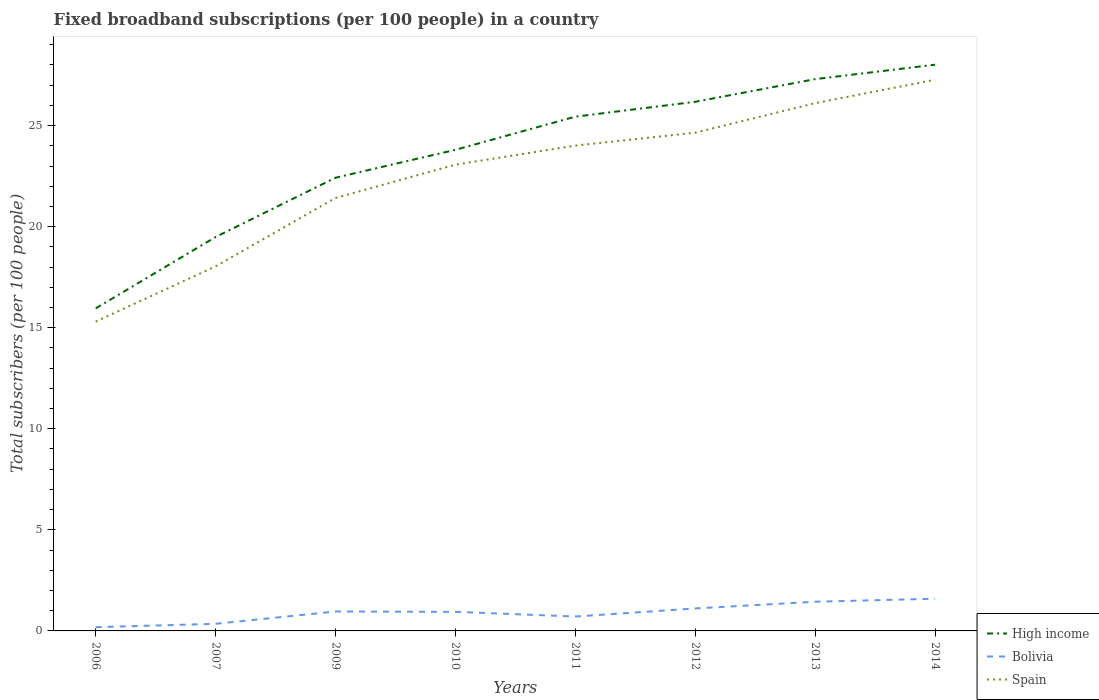Across all years, what is the maximum number of broadband subscriptions in Bolivia?
Provide a short and direct response. 0.18. In which year was the number of broadband subscriptions in Spain maximum?
Give a very brief answer. 2006. What is the total number of broadband subscriptions in Spain in the graph?
Your answer should be very brief. -5.85. What is the difference between the highest and the second highest number of broadband subscriptions in Spain?
Provide a succinct answer. 11.97. Are the values on the major ticks of Y-axis written in scientific E-notation?
Your answer should be compact. No. Does the graph contain any zero values?
Provide a short and direct response. No. Does the graph contain grids?
Keep it short and to the point. No. How many legend labels are there?
Your response must be concise. 3. How are the legend labels stacked?
Give a very brief answer. Vertical. What is the title of the graph?
Offer a terse response. Fixed broadband subscriptions (per 100 people) in a country. What is the label or title of the X-axis?
Provide a short and direct response. Years. What is the label or title of the Y-axis?
Provide a succinct answer. Total subscribers (per 100 people). What is the Total subscribers (per 100 people) in High income in 2006?
Make the answer very short. 15.96. What is the Total subscribers (per 100 people) of Bolivia in 2006?
Offer a terse response. 0.18. What is the Total subscribers (per 100 people) of Spain in 2006?
Provide a short and direct response. 15.3. What is the Total subscribers (per 100 people) in High income in 2007?
Your answer should be very brief. 19.49. What is the Total subscribers (per 100 people) of Bolivia in 2007?
Your response must be concise. 0.35. What is the Total subscribers (per 100 people) of Spain in 2007?
Offer a very short reply. 18.04. What is the Total subscribers (per 100 people) of High income in 2009?
Make the answer very short. 22.42. What is the Total subscribers (per 100 people) in Bolivia in 2009?
Provide a short and direct response. 0.96. What is the Total subscribers (per 100 people) of Spain in 2009?
Give a very brief answer. 21.42. What is the Total subscribers (per 100 people) in High income in 2010?
Ensure brevity in your answer.  23.8. What is the Total subscribers (per 100 people) of Bolivia in 2010?
Keep it short and to the point. 0.94. What is the Total subscribers (per 100 people) in Spain in 2010?
Your answer should be compact. 23.07. What is the Total subscribers (per 100 people) of High income in 2011?
Give a very brief answer. 25.44. What is the Total subscribers (per 100 people) in Bolivia in 2011?
Keep it short and to the point. 0.71. What is the Total subscribers (per 100 people) of Spain in 2011?
Make the answer very short. 24.01. What is the Total subscribers (per 100 people) of High income in 2012?
Ensure brevity in your answer.  26.18. What is the Total subscribers (per 100 people) in Bolivia in 2012?
Ensure brevity in your answer.  1.11. What is the Total subscribers (per 100 people) of Spain in 2012?
Provide a short and direct response. 24.65. What is the Total subscribers (per 100 people) of High income in 2013?
Your response must be concise. 27.3. What is the Total subscribers (per 100 people) in Bolivia in 2013?
Offer a very short reply. 1.44. What is the Total subscribers (per 100 people) in Spain in 2013?
Make the answer very short. 26.11. What is the Total subscribers (per 100 people) of High income in 2014?
Provide a succinct answer. 28.01. What is the Total subscribers (per 100 people) of Bolivia in 2014?
Ensure brevity in your answer.  1.59. What is the Total subscribers (per 100 people) in Spain in 2014?
Keep it short and to the point. 27.27. Across all years, what is the maximum Total subscribers (per 100 people) of High income?
Your response must be concise. 28.01. Across all years, what is the maximum Total subscribers (per 100 people) in Bolivia?
Make the answer very short. 1.59. Across all years, what is the maximum Total subscribers (per 100 people) of Spain?
Provide a succinct answer. 27.27. Across all years, what is the minimum Total subscribers (per 100 people) of High income?
Your answer should be compact. 15.96. Across all years, what is the minimum Total subscribers (per 100 people) in Bolivia?
Your response must be concise. 0.18. Across all years, what is the minimum Total subscribers (per 100 people) of Spain?
Ensure brevity in your answer.  15.3. What is the total Total subscribers (per 100 people) of High income in the graph?
Ensure brevity in your answer.  188.59. What is the total Total subscribers (per 100 people) of Bolivia in the graph?
Make the answer very short. 7.3. What is the total Total subscribers (per 100 people) of Spain in the graph?
Keep it short and to the point. 179.86. What is the difference between the Total subscribers (per 100 people) of High income in 2006 and that in 2007?
Make the answer very short. -3.53. What is the difference between the Total subscribers (per 100 people) of Bolivia in 2006 and that in 2007?
Offer a terse response. -0.17. What is the difference between the Total subscribers (per 100 people) in Spain in 2006 and that in 2007?
Provide a succinct answer. -2.73. What is the difference between the Total subscribers (per 100 people) in High income in 2006 and that in 2009?
Offer a very short reply. -6.46. What is the difference between the Total subscribers (per 100 people) in Bolivia in 2006 and that in 2009?
Provide a short and direct response. -0.78. What is the difference between the Total subscribers (per 100 people) in Spain in 2006 and that in 2009?
Make the answer very short. -6.12. What is the difference between the Total subscribers (per 100 people) of High income in 2006 and that in 2010?
Provide a short and direct response. -7.84. What is the difference between the Total subscribers (per 100 people) in Bolivia in 2006 and that in 2010?
Keep it short and to the point. -0.76. What is the difference between the Total subscribers (per 100 people) in Spain in 2006 and that in 2010?
Provide a short and direct response. -7.76. What is the difference between the Total subscribers (per 100 people) of High income in 2006 and that in 2011?
Your answer should be very brief. -9.49. What is the difference between the Total subscribers (per 100 people) of Bolivia in 2006 and that in 2011?
Give a very brief answer. -0.53. What is the difference between the Total subscribers (per 100 people) in Spain in 2006 and that in 2011?
Provide a succinct answer. -8.71. What is the difference between the Total subscribers (per 100 people) in High income in 2006 and that in 2012?
Ensure brevity in your answer.  -10.22. What is the difference between the Total subscribers (per 100 people) in Bolivia in 2006 and that in 2012?
Offer a terse response. -0.93. What is the difference between the Total subscribers (per 100 people) of Spain in 2006 and that in 2012?
Offer a terse response. -9.35. What is the difference between the Total subscribers (per 100 people) in High income in 2006 and that in 2013?
Your response must be concise. -11.34. What is the difference between the Total subscribers (per 100 people) in Bolivia in 2006 and that in 2013?
Offer a terse response. -1.26. What is the difference between the Total subscribers (per 100 people) of Spain in 2006 and that in 2013?
Keep it short and to the point. -10.81. What is the difference between the Total subscribers (per 100 people) of High income in 2006 and that in 2014?
Offer a terse response. -12.06. What is the difference between the Total subscribers (per 100 people) in Bolivia in 2006 and that in 2014?
Ensure brevity in your answer.  -1.41. What is the difference between the Total subscribers (per 100 people) of Spain in 2006 and that in 2014?
Offer a terse response. -11.97. What is the difference between the Total subscribers (per 100 people) of High income in 2007 and that in 2009?
Provide a succinct answer. -2.93. What is the difference between the Total subscribers (per 100 people) of Bolivia in 2007 and that in 2009?
Your answer should be compact. -0.61. What is the difference between the Total subscribers (per 100 people) of Spain in 2007 and that in 2009?
Give a very brief answer. -3.38. What is the difference between the Total subscribers (per 100 people) of High income in 2007 and that in 2010?
Ensure brevity in your answer.  -4.31. What is the difference between the Total subscribers (per 100 people) in Bolivia in 2007 and that in 2010?
Ensure brevity in your answer.  -0.59. What is the difference between the Total subscribers (per 100 people) of Spain in 2007 and that in 2010?
Offer a very short reply. -5.03. What is the difference between the Total subscribers (per 100 people) in High income in 2007 and that in 2011?
Offer a very short reply. -5.95. What is the difference between the Total subscribers (per 100 people) in Bolivia in 2007 and that in 2011?
Your response must be concise. -0.36. What is the difference between the Total subscribers (per 100 people) in Spain in 2007 and that in 2011?
Your response must be concise. -5.97. What is the difference between the Total subscribers (per 100 people) of High income in 2007 and that in 2012?
Offer a very short reply. -6.69. What is the difference between the Total subscribers (per 100 people) in Bolivia in 2007 and that in 2012?
Keep it short and to the point. -0.76. What is the difference between the Total subscribers (per 100 people) of Spain in 2007 and that in 2012?
Your response must be concise. -6.61. What is the difference between the Total subscribers (per 100 people) of High income in 2007 and that in 2013?
Keep it short and to the point. -7.81. What is the difference between the Total subscribers (per 100 people) in Bolivia in 2007 and that in 2013?
Offer a very short reply. -1.09. What is the difference between the Total subscribers (per 100 people) in Spain in 2007 and that in 2013?
Offer a very short reply. -8.07. What is the difference between the Total subscribers (per 100 people) of High income in 2007 and that in 2014?
Your answer should be compact. -8.52. What is the difference between the Total subscribers (per 100 people) of Bolivia in 2007 and that in 2014?
Keep it short and to the point. -1.24. What is the difference between the Total subscribers (per 100 people) in Spain in 2007 and that in 2014?
Provide a short and direct response. -9.23. What is the difference between the Total subscribers (per 100 people) of High income in 2009 and that in 2010?
Keep it short and to the point. -1.38. What is the difference between the Total subscribers (per 100 people) of Bolivia in 2009 and that in 2010?
Offer a terse response. 0.02. What is the difference between the Total subscribers (per 100 people) in Spain in 2009 and that in 2010?
Your response must be concise. -1.65. What is the difference between the Total subscribers (per 100 people) in High income in 2009 and that in 2011?
Provide a short and direct response. -3.02. What is the difference between the Total subscribers (per 100 people) in Bolivia in 2009 and that in 2011?
Ensure brevity in your answer.  0.25. What is the difference between the Total subscribers (per 100 people) of Spain in 2009 and that in 2011?
Offer a very short reply. -2.59. What is the difference between the Total subscribers (per 100 people) in High income in 2009 and that in 2012?
Your answer should be very brief. -3.76. What is the difference between the Total subscribers (per 100 people) of Bolivia in 2009 and that in 2012?
Keep it short and to the point. -0.15. What is the difference between the Total subscribers (per 100 people) of Spain in 2009 and that in 2012?
Give a very brief answer. -3.23. What is the difference between the Total subscribers (per 100 people) in High income in 2009 and that in 2013?
Make the answer very short. -4.88. What is the difference between the Total subscribers (per 100 people) of Bolivia in 2009 and that in 2013?
Keep it short and to the point. -0.48. What is the difference between the Total subscribers (per 100 people) in Spain in 2009 and that in 2013?
Provide a short and direct response. -4.69. What is the difference between the Total subscribers (per 100 people) of High income in 2009 and that in 2014?
Ensure brevity in your answer.  -5.59. What is the difference between the Total subscribers (per 100 people) of Bolivia in 2009 and that in 2014?
Ensure brevity in your answer.  -0.63. What is the difference between the Total subscribers (per 100 people) in Spain in 2009 and that in 2014?
Keep it short and to the point. -5.85. What is the difference between the Total subscribers (per 100 people) in High income in 2010 and that in 2011?
Your answer should be very brief. -1.64. What is the difference between the Total subscribers (per 100 people) in Bolivia in 2010 and that in 2011?
Your answer should be compact. 0.23. What is the difference between the Total subscribers (per 100 people) in Spain in 2010 and that in 2011?
Your answer should be compact. -0.94. What is the difference between the Total subscribers (per 100 people) of High income in 2010 and that in 2012?
Make the answer very short. -2.38. What is the difference between the Total subscribers (per 100 people) of Bolivia in 2010 and that in 2012?
Your answer should be very brief. -0.17. What is the difference between the Total subscribers (per 100 people) in Spain in 2010 and that in 2012?
Provide a succinct answer. -1.58. What is the difference between the Total subscribers (per 100 people) in High income in 2010 and that in 2013?
Make the answer very short. -3.5. What is the difference between the Total subscribers (per 100 people) of Bolivia in 2010 and that in 2013?
Your answer should be compact. -0.5. What is the difference between the Total subscribers (per 100 people) in Spain in 2010 and that in 2013?
Offer a terse response. -3.04. What is the difference between the Total subscribers (per 100 people) of High income in 2010 and that in 2014?
Offer a terse response. -4.21. What is the difference between the Total subscribers (per 100 people) of Bolivia in 2010 and that in 2014?
Make the answer very short. -0.65. What is the difference between the Total subscribers (per 100 people) of Spain in 2010 and that in 2014?
Your answer should be compact. -4.2. What is the difference between the Total subscribers (per 100 people) of High income in 2011 and that in 2012?
Keep it short and to the point. -0.74. What is the difference between the Total subscribers (per 100 people) in Bolivia in 2011 and that in 2012?
Make the answer very short. -0.4. What is the difference between the Total subscribers (per 100 people) in Spain in 2011 and that in 2012?
Offer a terse response. -0.64. What is the difference between the Total subscribers (per 100 people) of High income in 2011 and that in 2013?
Provide a succinct answer. -1.86. What is the difference between the Total subscribers (per 100 people) in Bolivia in 2011 and that in 2013?
Keep it short and to the point. -0.73. What is the difference between the Total subscribers (per 100 people) in Spain in 2011 and that in 2013?
Offer a terse response. -2.1. What is the difference between the Total subscribers (per 100 people) of High income in 2011 and that in 2014?
Your response must be concise. -2.57. What is the difference between the Total subscribers (per 100 people) in Bolivia in 2011 and that in 2014?
Ensure brevity in your answer.  -0.88. What is the difference between the Total subscribers (per 100 people) in Spain in 2011 and that in 2014?
Your answer should be very brief. -3.26. What is the difference between the Total subscribers (per 100 people) of High income in 2012 and that in 2013?
Your answer should be compact. -1.12. What is the difference between the Total subscribers (per 100 people) of Bolivia in 2012 and that in 2013?
Provide a short and direct response. -0.33. What is the difference between the Total subscribers (per 100 people) in Spain in 2012 and that in 2013?
Provide a short and direct response. -1.46. What is the difference between the Total subscribers (per 100 people) in High income in 2012 and that in 2014?
Keep it short and to the point. -1.83. What is the difference between the Total subscribers (per 100 people) in Bolivia in 2012 and that in 2014?
Provide a succinct answer. -0.48. What is the difference between the Total subscribers (per 100 people) in Spain in 2012 and that in 2014?
Your answer should be compact. -2.62. What is the difference between the Total subscribers (per 100 people) of High income in 2013 and that in 2014?
Provide a succinct answer. -0.71. What is the difference between the Total subscribers (per 100 people) in Bolivia in 2013 and that in 2014?
Your answer should be compact. -0.15. What is the difference between the Total subscribers (per 100 people) in Spain in 2013 and that in 2014?
Give a very brief answer. -1.16. What is the difference between the Total subscribers (per 100 people) of High income in 2006 and the Total subscribers (per 100 people) of Bolivia in 2007?
Make the answer very short. 15.61. What is the difference between the Total subscribers (per 100 people) in High income in 2006 and the Total subscribers (per 100 people) in Spain in 2007?
Ensure brevity in your answer.  -2.08. What is the difference between the Total subscribers (per 100 people) in Bolivia in 2006 and the Total subscribers (per 100 people) in Spain in 2007?
Offer a very short reply. -17.85. What is the difference between the Total subscribers (per 100 people) of High income in 2006 and the Total subscribers (per 100 people) of Bolivia in 2009?
Keep it short and to the point. 14.99. What is the difference between the Total subscribers (per 100 people) in High income in 2006 and the Total subscribers (per 100 people) in Spain in 2009?
Your answer should be compact. -5.46. What is the difference between the Total subscribers (per 100 people) of Bolivia in 2006 and the Total subscribers (per 100 people) of Spain in 2009?
Offer a very short reply. -21.24. What is the difference between the Total subscribers (per 100 people) of High income in 2006 and the Total subscribers (per 100 people) of Bolivia in 2010?
Offer a very short reply. 15.01. What is the difference between the Total subscribers (per 100 people) in High income in 2006 and the Total subscribers (per 100 people) in Spain in 2010?
Your answer should be very brief. -7.11. What is the difference between the Total subscribers (per 100 people) of Bolivia in 2006 and the Total subscribers (per 100 people) of Spain in 2010?
Make the answer very short. -22.88. What is the difference between the Total subscribers (per 100 people) of High income in 2006 and the Total subscribers (per 100 people) of Bolivia in 2011?
Give a very brief answer. 15.24. What is the difference between the Total subscribers (per 100 people) of High income in 2006 and the Total subscribers (per 100 people) of Spain in 2011?
Make the answer very short. -8.05. What is the difference between the Total subscribers (per 100 people) of Bolivia in 2006 and the Total subscribers (per 100 people) of Spain in 2011?
Provide a succinct answer. -23.82. What is the difference between the Total subscribers (per 100 people) in High income in 2006 and the Total subscribers (per 100 people) in Bolivia in 2012?
Keep it short and to the point. 14.84. What is the difference between the Total subscribers (per 100 people) in High income in 2006 and the Total subscribers (per 100 people) in Spain in 2012?
Provide a short and direct response. -8.69. What is the difference between the Total subscribers (per 100 people) in Bolivia in 2006 and the Total subscribers (per 100 people) in Spain in 2012?
Give a very brief answer. -24.46. What is the difference between the Total subscribers (per 100 people) of High income in 2006 and the Total subscribers (per 100 people) of Bolivia in 2013?
Your response must be concise. 14.51. What is the difference between the Total subscribers (per 100 people) in High income in 2006 and the Total subscribers (per 100 people) in Spain in 2013?
Offer a very short reply. -10.15. What is the difference between the Total subscribers (per 100 people) in Bolivia in 2006 and the Total subscribers (per 100 people) in Spain in 2013?
Offer a very short reply. -25.92. What is the difference between the Total subscribers (per 100 people) of High income in 2006 and the Total subscribers (per 100 people) of Bolivia in 2014?
Offer a terse response. 14.36. What is the difference between the Total subscribers (per 100 people) of High income in 2006 and the Total subscribers (per 100 people) of Spain in 2014?
Your answer should be compact. -11.31. What is the difference between the Total subscribers (per 100 people) in Bolivia in 2006 and the Total subscribers (per 100 people) in Spain in 2014?
Your answer should be very brief. -27.08. What is the difference between the Total subscribers (per 100 people) of High income in 2007 and the Total subscribers (per 100 people) of Bolivia in 2009?
Offer a terse response. 18.53. What is the difference between the Total subscribers (per 100 people) of High income in 2007 and the Total subscribers (per 100 people) of Spain in 2009?
Offer a terse response. -1.93. What is the difference between the Total subscribers (per 100 people) of Bolivia in 2007 and the Total subscribers (per 100 people) of Spain in 2009?
Give a very brief answer. -21.07. What is the difference between the Total subscribers (per 100 people) of High income in 2007 and the Total subscribers (per 100 people) of Bolivia in 2010?
Keep it short and to the point. 18.54. What is the difference between the Total subscribers (per 100 people) of High income in 2007 and the Total subscribers (per 100 people) of Spain in 2010?
Give a very brief answer. -3.58. What is the difference between the Total subscribers (per 100 people) of Bolivia in 2007 and the Total subscribers (per 100 people) of Spain in 2010?
Ensure brevity in your answer.  -22.71. What is the difference between the Total subscribers (per 100 people) of High income in 2007 and the Total subscribers (per 100 people) of Bolivia in 2011?
Your answer should be very brief. 18.78. What is the difference between the Total subscribers (per 100 people) of High income in 2007 and the Total subscribers (per 100 people) of Spain in 2011?
Your answer should be compact. -4.52. What is the difference between the Total subscribers (per 100 people) in Bolivia in 2007 and the Total subscribers (per 100 people) in Spain in 2011?
Offer a very short reply. -23.66. What is the difference between the Total subscribers (per 100 people) of High income in 2007 and the Total subscribers (per 100 people) of Bolivia in 2012?
Your answer should be compact. 18.38. What is the difference between the Total subscribers (per 100 people) of High income in 2007 and the Total subscribers (per 100 people) of Spain in 2012?
Give a very brief answer. -5.16. What is the difference between the Total subscribers (per 100 people) in Bolivia in 2007 and the Total subscribers (per 100 people) in Spain in 2012?
Offer a terse response. -24.3. What is the difference between the Total subscribers (per 100 people) in High income in 2007 and the Total subscribers (per 100 people) in Bolivia in 2013?
Your answer should be very brief. 18.04. What is the difference between the Total subscribers (per 100 people) in High income in 2007 and the Total subscribers (per 100 people) in Spain in 2013?
Provide a short and direct response. -6.62. What is the difference between the Total subscribers (per 100 people) of Bolivia in 2007 and the Total subscribers (per 100 people) of Spain in 2013?
Your answer should be compact. -25.76. What is the difference between the Total subscribers (per 100 people) of High income in 2007 and the Total subscribers (per 100 people) of Bolivia in 2014?
Give a very brief answer. 17.9. What is the difference between the Total subscribers (per 100 people) of High income in 2007 and the Total subscribers (per 100 people) of Spain in 2014?
Make the answer very short. -7.78. What is the difference between the Total subscribers (per 100 people) of Bolivia in 2007 and the Total subscribers (per 100 people) of Spain in 2014?
Offer a very short reply. -26.92. What is the difference between the Total subscribers (per 100 people) in High income in 2009 and the Total subscribers (per 100 people) in Bolivia in 2010?
Ensure brevity in your answer.  21.48. What is the difference between the Total subscribers (per 100 people) in High income in 2009 and the Total subscribers (per 100 people) in Spain in 2010?
Offer a very short reply. -0.65. What is the difference between the Total subscribers (per 100 people) of Bolivia in 2009 and the Total subscribers (per 100 people) of Spain in 2010?
Offer a terse response. -22.1. What is the difference between the Total subscribers (per 100 people) of High income in 2009 and the Total subscribers (per 100 people) of Bolivia in 2011?
Make the answer very short. 21.71. What is the difference between the Total subscribers (per 100 people) in High income in 2009 and the Total subscribers (per 100 people) in Spain in 2011?
Your answer should be compact. -1.59. What is the difference between the Total subscribers (per 100 people) of Bolivia in 2009 and the Total subscribers (per 100 people) of Spain in 2011?
Your response must be concise. -23.05. What is the difference between the Total subscribers (per 100 people) of High income in 2009 and the Total subscribers (per 100 people) of Bolivia in 2012?
Ensure brevity in your answer.  21.31. What is the difference between the Total subscribers (per 100 people) of High income in 2009 and the Total subscribers (per 100 people) of Spain in 2012?
Provide a short and direct response. -2.23. What is the difference between the Total subscribers (per 100 people) in Bolivia in 2009 and the Total subscribers (per 100 people) in Spain in 2012?
Give a very brief answer. -23.69. What is the difference between the Total subscribers (per 100 people) of High income in 2009 and the Total subscribers (per 100 people) of Bolivia in 2013?
Keep it short and to the point. 20.98. What is the difference between the Total subscribers (per 100 people) of High income in 2009 and the Total subscribers (per 100 people) of Spain in 2013?
Offer a terse response. -3.69. What is the difference between the Total subscribers (per 100 people) of Bolivia in 2009 and the Total subscribers (per 100 people) of Spain in 2013?
Your response must be concise. -25.15. What is the difference between the Total subscribers (per 100 people) in High income in 2009 and the Total subscribers (per 100 people) in Bolivia in 2014?
Ensure brevity in your answer.  20.83. What is the difference between the Total subscribers (per 100 people) of High income in 2009 and the Total subscribers (per 100 people) of Spain in 2014?
Your answer should be very brief. -4.85. What is the difference between the Total subscribers (per 100 people) of Bolivia in 2009 and the Total subscribers (per 100 people) of Spain in 2014?
Your answer should be compact. -26.31. What is the difference between the Total subscribers (per 100 people) in High income in 2010 and the Total subscribers (per 100 people) in Bolivia in 2011?
Keep it short and to the point. 23.09. What is the difference between the Total subscribers (per 100 people) of High income in 2010 and the Total subscribers (per 100 people) of Spain in 2011?
Offer a very short reply. -0.21. What is the difference between the Total subscribers (per 100 people) of Bolivia in 2010 and the Total subscribers (per 100 people) of Spain in 2011?
Your response must be concise. -23.06. What is the difference between the Total subscribers (per 100 people) in High income in 2010 and the Total subscribers (per 100 people) in Bolivia in 2012?
Make the answer very short. 22.69. What is the difference between the Total subscribers (per 100 people) in High income in 2010 and the Total subscribers (per 100 people) in Spain in 2012?
Make the answer very short. -0.85. What is the difference between the Total subscribers (per 100 people) in Bolivia in 2010 and the Total subscribers (per 100 people) in Spain in 2012?
Ensure brevity in your answer.  -23.7. What is the difference between the Total subscribers (per 100 people) of High income in 2010 and the Total subscribers (per 100 people) of Bolivia in 2013?
Give a very brief answer. 22.36. What is the difference between the Total subscribers (per 100 people) of High income in 2010 and the Total subscribers (per 100 people) of Spain in 2013?
Ensure brevity in your answer.  -2.31. What is the difference between the Total subscribers (per 100 people) in Bolivia in 2010 and the Total subscribers (per 100 people) in Spain in 2013?
Ensure brevity in your answer.  -25.16. What is the difference between the Total subscribers (per 100 people) in High income in 2010 and the Total subscribers (per 100 people) in Bolivia in 2014?
Make the answer very short. 22.21. What is the difference between the Total subscribers (per 100 people) of High income in 2010 and the Total subscribers (per 100 people) of Spain in 2014?
Provide a short and direct response. -3.47. What is the difference between the Total subscribers (per 100 people) of Bolivia in 2010 and the Total subscribers (per 100 people) of Spain in 2014?
Provide a short and direct response. -26.32. What is the difference between the Total subscribers (per 100 people) in High income in 2011 and the Total subscribers (per 100 people) in Bolivia in 2012?
Provide a succinct answer. 24.33. What is the difference between the Total subscribers (per 100 people) in High income in 2011 and the Total subscribers (per 100 people) in Spain in 2012?
Your response must be concise. 0.79. What is the difference between the Total subscribers (per 100 people) of Bolivia in 2011 and the Total subscribers (per 100 people) of Spain in 2012?
Your answer should be compact. -23.94. What is the difference between the Total subscribers (per 100 people) of High income in 2011 and the Total subscribers (per 100 people) of Bolivia in 2013?
Your answer should be very brief. 24. What is the difference between the Total subscribers (per 100 people) in High income in 2011 and the Total subscribers (per 100 people) in Spain in 2013?
Offer a terse response. -0.67. What is the difference between the Total subscribers (per 100 people) of Bolivia in 2011 and the Total subscribers (per 100 people) of Spain in 2013?
Provide a short and direct response. -25.4. What is the difference between the Total subscribers (per 100 people) in High income in 2011 and the Total subscribers (per 100 people) in Bolivia in 2014?
Make the answer very short. 23.85. What is the difference between the Total subscribers (per 100 people) of High income in 2011 and the Total subscribers (per 100 people) of Spain in 2014?
Your response must be concise. -1.83. What is the difference between the Total subscribers (per 100 people) of Bolivia in 2011 and the Total subscribers (per 100 people) of Spain in 2014?
Give a very brief answer. -26.56. What is the difference between the Total subscribers (per 100 people) in High income in 2012 and the Total subscribers (per 100 people) in Bolivia in 2013?
Provide a succinct answer. 24.73. What is the difference between the Total subscribers (per 100 people) in High income in 2012 and the Total subscribers (per 100 people) in Spain in 2013?
Offer a very short reply. 0.07. What is the difference between the Total subscribers (per 100 people) in Bolivia in 2012 and the Total subscribers (per 100 people) in Spain in 2013?
Ensure brevity in your answer.  -25. What is the difference between the Total subscribers (per 100 people) of High income in 2012 and the Total subscribers (per 100 people) of Bolivia in 2014?
Ensure brevity in your answer.  24.58. What is the difference between the Total subscribers (per 100 people) of High income in 2012 and the Total subscribers (per 100 people) of Spain in 2014?
Offer a very short reply. -1.09. What is the difference between the Total subscribers (per 100 people) of Bolivia in 2012 and the Total subscribers (per 100 people) of Spain in 2014?
Your answer should be compact. -26.16. What is the difference between the Total subscribers (per 100 people) in High income in 2013 and the Total subscribers (per 100 people) in Bolivia in 2014?
Your answer should be very brief. 25.71. What is the difference between the Total subscribers (per 100 people) of High income in 2013 and the Total subscribers (per 100 people) of Spain in 2014?
Offer a terse response. 0.03. What is the difference between the Total subscribers (per 100 people) in Bolivia in 2013 and the Total subscribers (per 100 people) in Spain in 2014?
Provide a succinct answer. -25.82. What is the average Total subscribers (per 100 people) of High income per year?
Your answer should be very brief. 23.57. What is the average Total subscribers (per 100 people) in Spain per year?
Ensure brevity in your answer.  22.48. In the year 2006, what is the difference between the Total subscribers (per 100 people) of High income and Total subscribers (per 100 people) of Bolivia?
Provide a succinct answer. 15.77. In the year 2006, what is the difference between the Total subscribers (per 100 people) in High income and Total subscribers (per 100 people) in Spain?
Keep it short and to the point. 0.65. In the year 2006, what is the difference between the Total subscribers (per 100 people) of Bolivia and Total subscribers (per 100 people) of Spain?
Your answer should be very brief. -15.12. In the year 2007, what is the difference between the Total subscribers (per 100 people) of High income and Total subscribers (per 100 people) of Bolivia?
Keep it short and to the point. 19.14. In the year 2007, what is the difference between the Total subscribers (per 100 people) of High income and Total subscribers (per 100 people) of Spain?
Offer a very short reply. 1.45. In the year 2007, what is the difference between the Total subscribers (per 100 people) of Bolivia and Total subscribers (per 100 people) of Spain?
Offer a terse response. -17.69. In the year 2009, what is the difference between the Total subscribers (per 100 people) of High income and Total subscribers (per 100 people) of Bolivia?
Your answer should be compact. 21.46. In the year 2009, what is the difference between the Total subscribers (per 100 people) in Bolivia and Total subscribers (per 100 people) in Spain?
Give a very brief answer. -20.46. In the year 2010, what is the difference between the Total subscribers (per 100 people) of High income and Total subscribers (per 100 people) of Bolivia?
Give a very brief answer. 22.86. In the year 2010, what is the difference between the Total subscribers (per 100 people) in High income and Total subscribers (per 100 people) in Spain?
Provide a short and direct response. 0.73. In the year 2010, what is the difference between the Total subscribers (per 100 people) of Bolivia and Total subscribers (per 100 people) of Spain?
Make the answer very short. -22.12. In the year 2011, what is the difference between the Total subscribers (per 100 people) of High income and Total subscribers (per 100 people) of Bolivia?
Give a very brief answer. 24.73. In the year 2011, what is the difference between the Total subscribers (per 100 people) of High income and Total subscribers (per 100 people) of Spain?
Ensure brevity in your answer.  1.43. In the year 2011, what is the difference between the Total subscribers (per 100 people) of Bolivia and Total subscribers (per 100 people) of Spain?
Ensure brevity in your answer.  -23.3. In the year 2012, what is the difference between the Total subscribers (per 100 people) of High income and Total subscribers (per 100 people) of Bolivia?
Make the answer very short. 25.07. In the year 2012, what is the difference between the Total subscribers (per 100 people) in High income and Total subscribers (per 100 people) in Spain?
Offer a very short reply. 1.53. In the year 2012, what is the difference between the Total subscribers (per 100 people) in Bolivia and Total subscribers (per 100 people) in Spain?
Keep it short and to the point. -23.54. In the year 2013, what is the difference between the Total subscribers (per 100 people) in High income and Total subscribers (per 100 people) in Bolivia?
Give a very brief answer. 25.85. In the year 2013, what is the difference between the Total subscribers (per 100 people) of High income and Total subscribers (per 100 people) of Spain?
Give a very brief answer. 1.19. In the year 2013, what is the difference between the Total subscribers (per 100 people) of Bolivia and Total subscribers (per 100 people) of Spain?
Offer a very short reply. -24.66. In the year 2014, what is the difference between the Total subscribers (per 100 people) of High income and Total subscribers (per 100 people) of Bolivia?
Make the answer very short. 26.42. In the year 2014, what is the difference between the Total subscribers (per 100 people) in High income and Total subscribers (per 100 people) in Spain?
Your answer should be compact. 0.74. In the year 2014, what is the difference between the Total subscribers (per 100 people) in Bolivia and Total subscribers (per 100 people) in Spain?
Provide a short and direct response. -25.68. What is the ratio of the Total subscribers (per 100 people) of High income in 2006 to that in 2007?
Your answer should be compact. 0.82. What is the ratio of the Total subscribers (per 100 people) in Bolivia in 2006 to that in 2007?
Give a very brief answer. 0.53. What is the ratio of the Total subscribers (per 100 people) of Spain in 2006 to that in 2007?
Offer a very short reply. 0.85. What is the ratio of the Total subscribers (per 100 people) of High income in 2006 to that in 2009?
Offer a terse response. 0.71. What is the ratio of the Total subscribers (per 100 people) in Bolivia in 2006 to that in 2009?
Your answer should be very brief. 0.19. What is the ratio of the Total subscribers (per 100 people) in Spain in 2006 to that in 2009?
Keep it short and to the point. 0.71. What is the ratio of the Total subscribers (per 100 people) in High income in 2006 to that in 2010?
Make the answer very short. 0.67. What is the ratio of the Total subscribers (per 100 people) in Bolivia in 2006 to that in 2010?
Provide a succinct answer. 0.2. What is the ratio of the Total subscribers (per 100 people) in Spain in 2006 to that in 2010?
Your answer should be very brief. 0.66. What is the ratio of the Total subscribers (per 100 people) in High income in 2006 to that in 2011?
Your answer should be very brief. 0.63. What is the ratio of the Total subscribers (per 100 people) of Bolivia in 2006 to that in 2011?
Your answer should be compact. 0.26. What is the ratio of the Total subscribers (per 100 people) in Spain in 2006 to that in 2011?
Your answer should be very brief. 0.64. What is the ratio of the Total subscribers (per 100 people) of High income in 2006 to that in 2012?
Offer a terse response. 0.61. What is the ratio of the Total subscribers (per 100 people) of Bolivia in 2006 to that in 2012?
Give a very brief answer. 0.17. What is the ratio of the Total subscribers (per 100 people) of Spain in 2006 to that in 2012?
Ensure brevity in your answer.  0.62. What is the ratio of the Total subscribers (per 100 people) of High income in 2006 to that in 2013?
Give a very brief answer. 0.58. What is the ratio of the Total subscribers (per 100 people) in Bolivia in 2006 to that in 2013?
Give a very brief answer. 0.13. What is the ratio of the Total subscribers (per 100 people) in Spain in 2006 to that in 2013?
Provide a succinct answer. 0.59. What is the ratio of the Total subscribers (per 100 people) in High income in 2006 to that in 2014?
Keep it short and to the point. 0.57. What is the ratio of the Total subscribers (per 100 people) in Bolivia in 2006 to that in 2014?
Your answer should be very brief. 0.12. What is the ratio of the Total subscribers (per 100 people) in Spain in 2006 to that in 2014?
Give a very brief answer. 0.56. What is the ratio of the Total subscribers (per 100 people) of High income in 2007 to that in 2009?
Give a very brief answer. 0.87. What is the ratio of the Total subscribers (per 100 people) of Bolivia in 2007 to that in 2009?
Ensure brevity in your answer.  0.36. What is the ratio of the Total subscribers (per 100 people) in Spain in 2007 to that in 2009?
Make the answer very short. 0.84. What is the ratio of the Total subscribers (per 100 people) of High income in 2007 to that in 2010?
Give a very brief answer. 0.82. What is the ratio of the Total subscribers (per 100 people) of Bolivia in 2007 to that in 2010?
Your answer should be compact. 0.37. What is the ratio of the Total subscribers (per 100 people) of Spain in 2007 to that in 2010?
Ensure brevity in your answer.  0.78. What is the ratio of the Total subscribers (per 100 people) of High income in 2007 to that in 2011?
Give a very brief answer. 0.77. What is the ratio of the Total subscribers (per 100 people) in Bolivia in 2007 to that in 2011?
Ensure brevity in your answer.  0.49. What is the ratio of the Total subscribers (per 100 people) of Spain in 2007 to that in 2011?
Keep it short and to the point. 0.75. What is the ratio of the Total subscribers (per 100 people) in High income in 2007 to that in 2012?
Provide a succinct answer. 0.74. What is the ratio of the Total subscribers (per 100 people) of Bolivia in 2007 to that in 2012?
Give a very brief answer. 0.32. What is the ratio of the Total subscribers (per 100 people) in Spain in 2007 to that in 2012?
Provide a short and direct response. 0.73. What is the ratio of the Total subscribers (per 100 people) in High income in 2007 to that in 2013?
Your response must be concise. 0.71. What is the ratio of the Total subscribers (per 100 people) in Bolivia in 2007 to that in 2013?
Offer a terse response. 0.24. What is the ratio of the Total subscribers (per 100 people) of Spain in 2007 to that in 2013?
Offer a terse response. 0.69. What is the ratio of the Total subscribers (per 100 people) of High income in 2007 to that in 2014?
Your answer should be compact. 0.7. What is the ratio of the Total subscribers (per 100 people) of Bolivia in 2007 to that in 2014?
Offer a very short reply. 0.22. What is the ratio of the Total subscribers (per 100 people) of Spain in 2007 to that in 2014?
Your response must be concise. 0.66. What is the ratio of the Total subscribers (per 100 people) of High income in 2009 to that in 2010?
Make the answer very short. 0.94. What is the ratio of the Total subscribers (per 100 people) in Bolivia in 2009 to that in 2010?
Offer a very short reply. 1.02. What is the ratio of the Total subscribers (per 100 people) of Spain in 2009 to that in 2010?
Ensure brevity in your answer.  0.93. What is the ratio of the Total subscribers (per 100 people) of High income in 2009 to that in 2011?
Make the answer very short. 0.88. What is the ratio of the Total subscribers (per 100 people) in Bolivia in 2009 to that in 2011?
Your response must be concise. 1.35. What is the ratio of the Total subscribers (per 100 people) in Spain in 2009 to that in 2011?
Your response must be concise. 0.89. What is the ratio of the Total subscribers (per 100 people) in High income in 2009 to that in 2012?
Your answer should be very brief. 0.86. What is the ratio of the Total subscribers (per 100 people) of Bolivia in 2009 to that in 2012?
Your response must be concise. 0.87. What is the ratio of the Total subscribers (per 100 people) in Spain in 2009 to that in 2012?
Provide a short and direct response. 0.87. What is the ratio of the Total subscribers (per 100 people) of High income in 2009 to that in 2013?
Your response must be concise. 0.82. What is the ratio of the Total subscribers (per 100 people) in Bolivia in 2009 to that in 2013?
Your response must be concise. 0.67. What is the ratio of the Total subscribers (per 100 people) of Spain in 2009 to that in 2013?
Provide a succinct answer. 0.82. What is the ratio of the Total subscribers (per 100 people) in High income in 2009 to that in 2014?
Your response must be concise. 0.8. What is the ratio of the Total subscribers (per 100 people) in Bolivia in 2009 to that in 2014?
Give a very brief answer. 0.6. What is the ratio of the Total subscribers (per 100 people) in Spain in 2009 to that in 2014?
Provide a succinct answer. 0.79. What is the ratio of the Total subscribers (per 100 people) in High income in 2010 to that in 2011?
Your answer should be compact. 0.94. What is the ratio of the Total subscribers (per 100 people) of Bolivia in 2010 to that in 2011?
Your answer should be very brief. 1.33. What is the ratio of the Total subscribers (per 100 people) in Spain in 2010 to that in 2011?
Give a very brief answer. 0.96. What is the ratio of the Total subscribers (per 100 people) of High income in 2010 to that in 2012?
Your answer should be very brief. 0.91. What is the ratio of the Total subscribers (per 100 people) in Bolivia in 2010 to that in 2012?
Provide a succinct answer. 0.85. What is the ratio of the Total subscribers (per 100 people) of Spain in 2010 to that in 2012?
Provide a short and direct response. 0.94. What is the ratio of the Total subscribers (per 100 people) in High income in 2010 to that in 2013?
Ensure brevity in your answer.  0.87. What is the ratio of the Total subscribers (per 100 people) in Bolivia in 2010 to that in 2013?
Keep it short and to the point. 0.65. What is the ratio of the Total subscribers (per 100 people) of Spain in 2010 to that in 2013?
Your response must be concise. 0.88. What is the ratio of the Total subscribers (per 100 people) in High income in 2010 to that in 2014?
Keep it short and to the point. 0.85. What is the ratio of the Total subscribers (per 100 people) of Bolivia in 2010 to that in 2014?
Offer a very short reply. 0.59. What is the ratio of the Total subscribers (per 100 people) in Spain in 2010 to that in 2014?
Your answer should be compact. 0.85. What is the ratio of the Total subscribers (per 100 people) of High income in 2011 to that in 2012?
Make the answer very short. 0.97. What is the ratio of the Total subscribers (per 100 people) in Bolivia in 2011 to that in 2012?
Your answer should be compact. 0.64. What is the ratio of the Total subscribers (per 100 people) in Spain in 2011 to that in 2012?
Keep it short and to the point. 0.97. What is the ratio of the Total subscribers (per 100 people) in High income in 2011 to that in 2013?
Your answer should be very brief. 0.93. What is the ratio of the Total subscribers (per 100 people) of Bolivia in 2011 to that in 2013?
Provide a short and direct response. 0.49. What is the ratio of the Total subscribers (per 100 people) in Spain in 2011 to that in 2013?
Ensure brevity in your answer.  0.92. What is the ratio of the Total subscribers (per 100 people) in High income in 2011 to that in 2014?
Give a very brief answer. 0.91. What is the ratio of the Total subscribers (per 100 people) of Bolivia in 2011 to that in 2014?
Your answer should be very brief. 0.45. What is the ratio of the Total subscribers (per 100 people) in Spain in 2011 to that in 2014?
Provide a succinct answer. 0.88. What is the ratio of the Total subscribers (per 100 people) of High income in 2012 to that in 2013?
Offer a terse response. 0.96. What is the ratio of the Total subscribers (per 100 people) in Bolivia in 2012 to that in 2013?
Ensure brevity in your answer.  0.77. What is the ratio of the Total subscribers (per 100 people) of Spain in 2012 to that in 2013?
Your answer should be very brief. 0.94. What is the ratio of the Total subscribers (per 100 people) in High income in 2012 to that in 2014?
Your answer should be very brief. 0.93. What is the ratio of the Total subscribers (per 100 people) in Bolivia in 2012 to that in 2014?
Make the answer very short. 0.7. What is the ratio of the Total subscribers (per 100 people) in Spain in 2012 to that in 2014?
Your response must be concise. 0.9. What is the ratio of the Total subscribers (per 100 people) of High income in 2013 to that in 2014?
Give a very brief answer. 0.97. What is the ratio of the Total subscribers (per 100 people) of Bolivia in 2013 to that in 2014?
Give a very brief answer. 0.91. What is the ratio of the Total subscribers (per 100 people) in Spain in 2013 to that in 2014?
Give a very brief answer. 0.96. What is the difference between the highest and the second highest Total subscribers (per 100 people) in High income?
Ensure brevity in your answer.  0.71. What is the difference between the highest and the second highest Total subscribers (per 100 people) in Bolivia?
Your answer should be compact. 0.15. What is the difference between the highest and the second highest Total subscribers (per 100 people) of Spain?
Keep it short and to the point. 1.16. What is the difference between the highest and the lowest Total subscribers (per 100 people) of High income?
Provide a short and direct response. 12.06. What is the difference between the highest and the lowest Total subscribers (per 100 people) of Bolivia?
Provide a short and direct response. 1.41. What is the difference between the highest and the lowest Total subscribers (per 100 people) in Spain?
Ensure brevity in your answer.  11.97. 